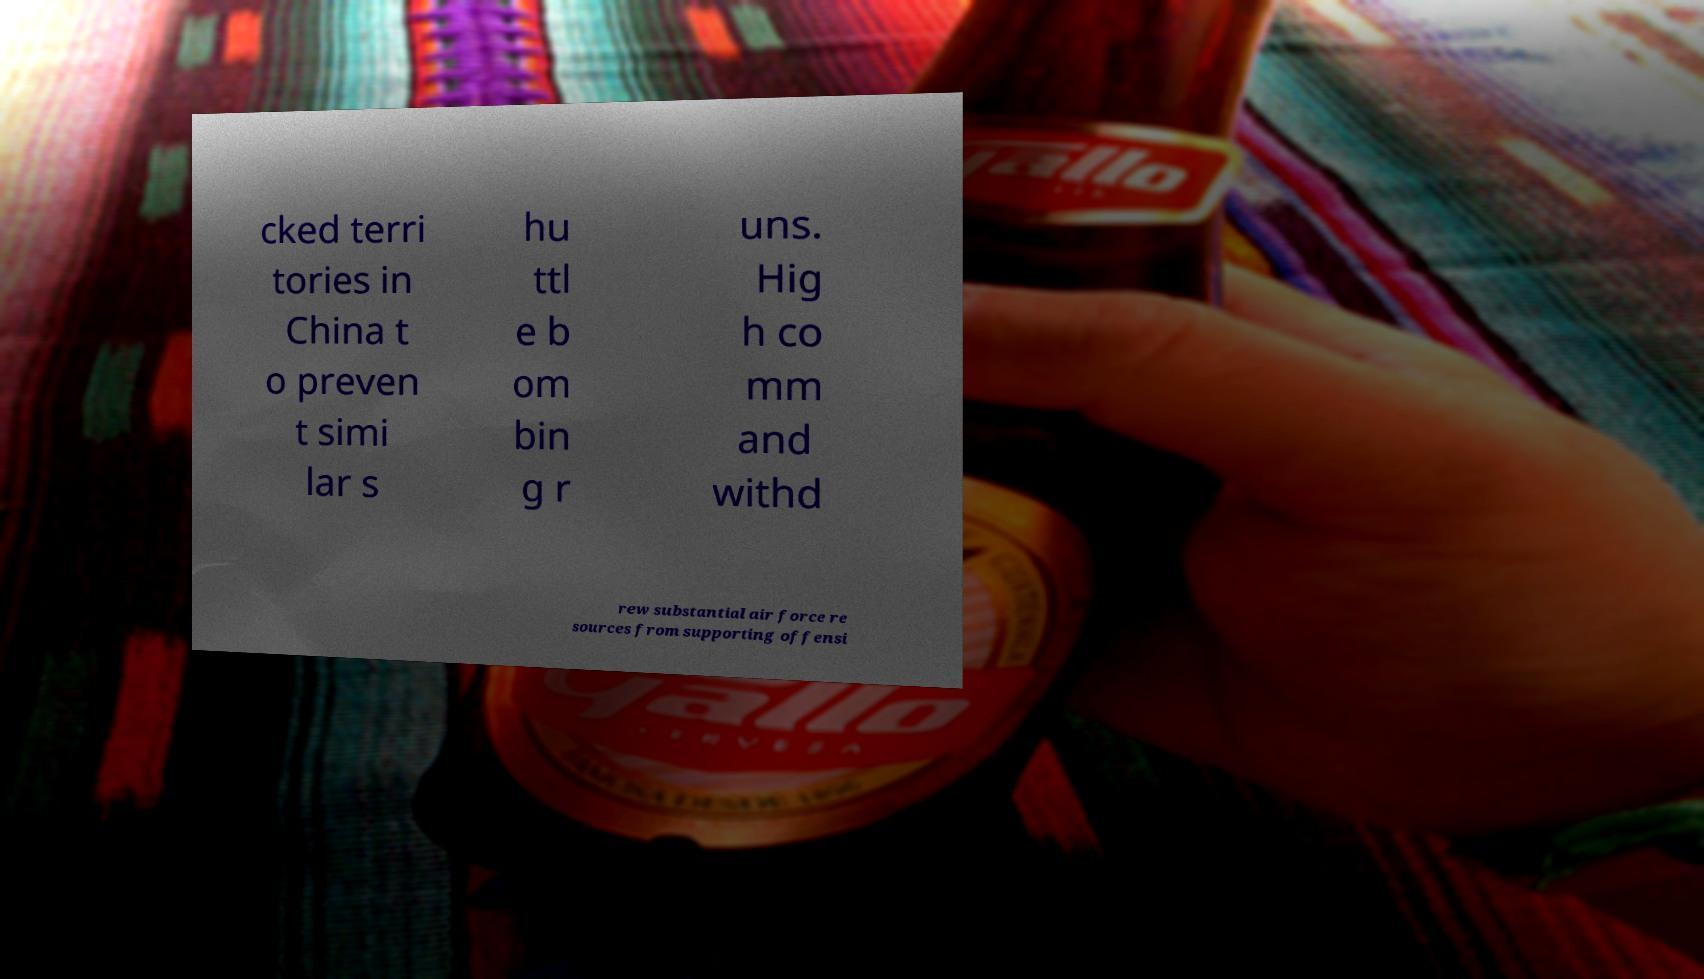Could you extract and type out the text from this image? cked terri tories in China t o preven t simi lar s hu ttl e b om bin g r uns. Hig h co mm and withd rew substantial air force re sources from supporting offensi 